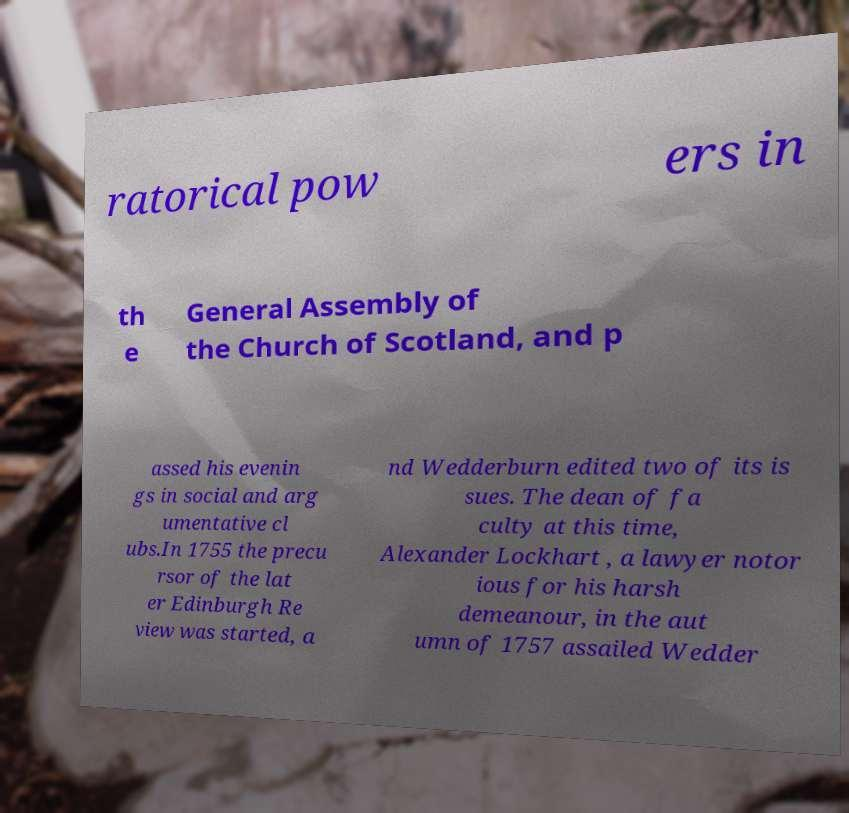Can you accurately transcribe the text from the provided image for me? ratorical pow ers in th e General Assembly of the Church of Scotland, and p assed his evenin gs in social and arg umentative cl ubs.In 1755 the precu rsor of the lat er Edinburgh Re view was started, a nd Wedderburn edited two of its is sues. The dean of fa culty at this time, Alexander Lockhart , a lawyer notor ious for his harsh demeanour, in the aut umn of 1757 assailed Wedder 